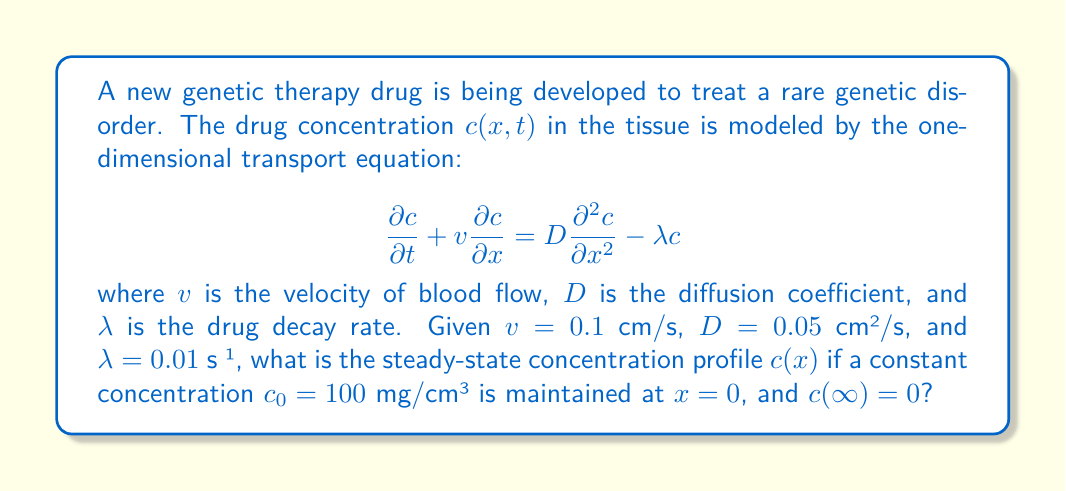Can you answer this question? To solve this problem, we need to follow these steps:

1) For the steady-state solution, the concentration doesn't change with time, so $\frac{\partial c}{\partial t} = 0$. The equation becomes:

   $$v\frac{dc}{dx} = D\frac{d^2c}{dx^2} - \lambda c$$

2) This is a second-order ordinary differential equation. Let's rearrange it:

   $$D\frac{d^2c}{dx^2} - v\frac{dc}{dx} - \lambda c = 0$$

3) The characteristic equation for this ODE is:

   $$Dr^2 - vr - \lambda = 0$$

4) Solving this quadratic equation:

   $$r = \frac{v \pm \sqrt{v^2 + 4D\lambda}}{2D}$$

5) Substituting the given values:

   $$r = \frac{0.1 \pm \sqrt{0.1^2 + 4(0.05)(0.01)}}{2(0.05)} = \frac{0.1 \pm \sqrt{0.01 + 0.002}}{0.1} = 1 \pm \sqrt{1.2}$$

6) The general solution is:

   $$c(x) = Ae^{r_1x} + Be^{r_2x}$$

   where $r_1 = 1 + \sqrt{1.2}$ and $r_2 = 1 - \sqrt{1.2}$

7) Applying the boundary conditions:
   - At $x = 0$, $c(0) = c_0 = 100$, so $A + B = 100$
   - As $x \to \infty$, $c(\infty) = 0$, which means $A = 0$ (since $r_1 > 0$)

8) Therefore, $B = 100$ and the solution is:

   $$c(x) = 100e^{(1-\sqrt{1.2})x}$$

9) Simplifying:

   $$c(x) = 100e^{-0.095x}$$

This is the steady-state concentration profile.
Answer: The steady-state concentration profile is given by:

$$c(x) = 100e^{-0.095x}$$ mg/cm³

where $x$ is the distance in cm from the source of drug administration. 